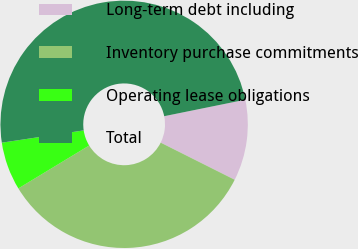Convert chart. <chart><loc_0><loc_0><loc_500><loc_500><pie_chart><fcel>Long-term debt including<fcel>Inventory purchase commitments<fcel>Operating lease obligations<fcel>Total<nl><fcel>10.59%<fcel>33.93%<fcel>6.3%<fcel>49.18%<nl></chart> 